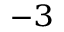Convert formula to latex. <formula><loc_0><loc_0><loc_500><loc_500>^ { - 3 }</formula> 